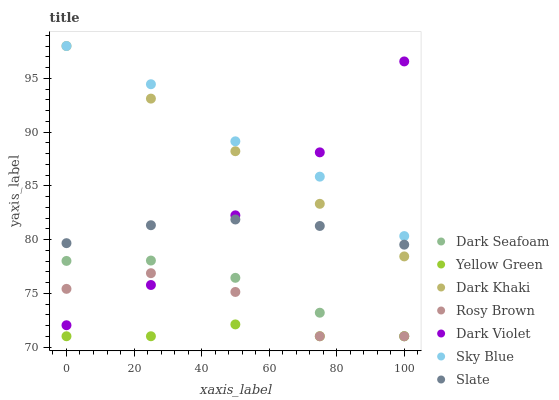Does Yellow Green have the minimum area under the curve?
Answer yes or no. Yes. Does Sky Blue have the maximum area under the curve?
Answer yes or no. Yes. Does Slate have the minimum area under the curve?
Answer yes or no. No. Does Slate have the maximum area under the curve?
Answer yes or no. No. Is Dark Khaki the smoothest?
Answer yes or no. Yes. Is Rosy Brown the roughest?
Answer yes or no. Yes. Is Slate the smoothest?
Answer yes or no. No. Is Slate the roughest?
Answer yes or no. No. Does Yellow Green have the lowest value?
Answer yes or no. Yes. Does Slate have the lowest value?
Answer yes or no. No. Does Sky Blue have the highest value?
Answer yes or no. Yes. Does Slate have the highest value?
Answer yes or no. No. Is Yellow Green less than Dark Khaki?
Answer yes or no. Yes. Is Sky Blue greater than Yellow Green?
Answer yes or no. Yes. Does Yellow Green intersect Dark Seafoam?
Answer yes or no. Yes. Is Yellow Green less than Dark Seafoam?
Answer yes or no. No. Is Yellow Green greater than Dark Seafoam?
Answer yes or no. No. Does Yellow Green intersect Dark Khaki?
Answer yes or no. No. 